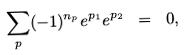Convert formula to latex. <formula><loc_0><loc_0><loc_500><loc_500>\sum _ { p } ( - 1 ) ^ { n _ { p } } e ^ { p _ { 1 } } e ^ { p _ { 2 } } \ = \ 0 ,</formula> 